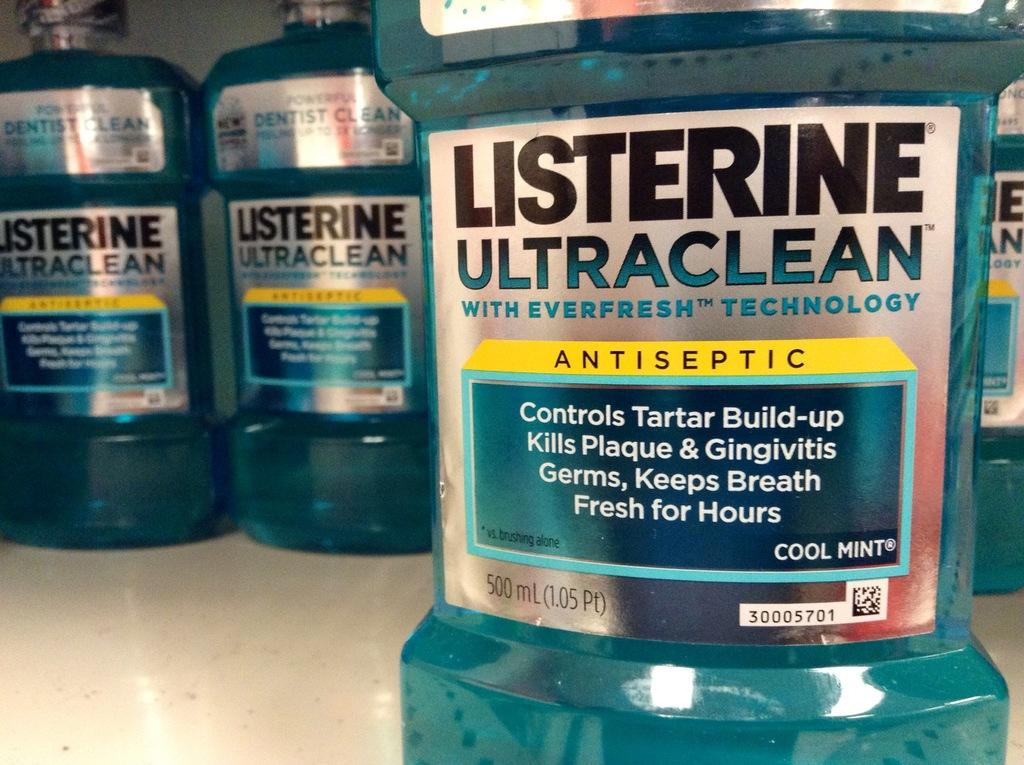<image>
Write a terse but informative summary of the picture. Bottle of Listerine Ultraclean in front of other bottles of Listerine. 